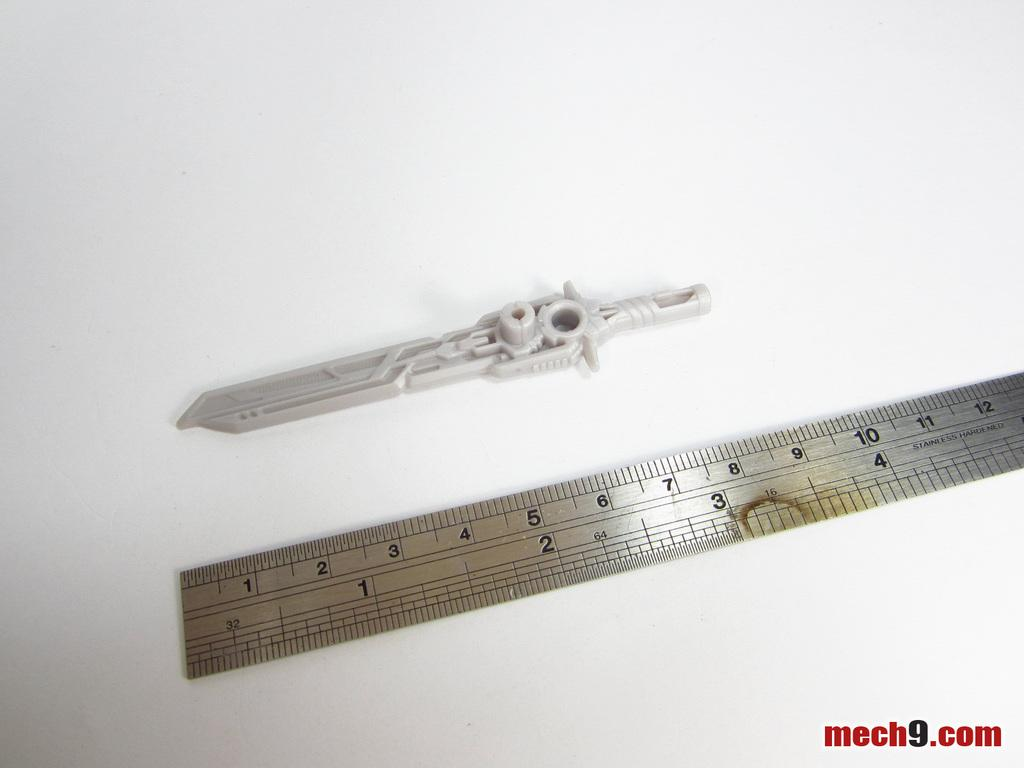<image>
Render a clear and concise summary of the photo. A ruler with the words Stainless Hardened by the 4 inch mark on the ruler 